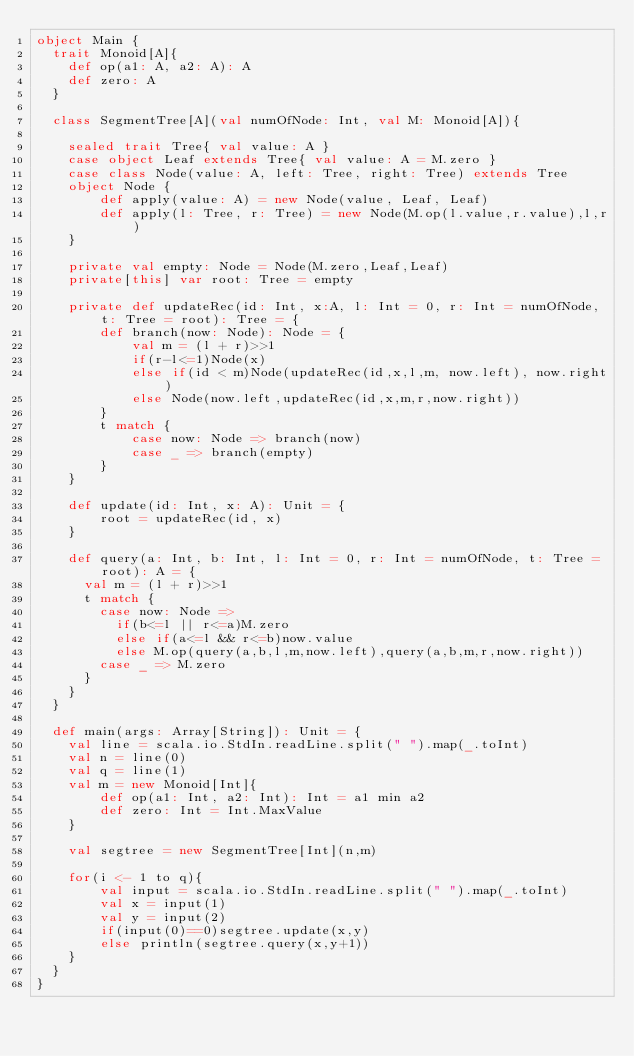Convert code to text. <code><loc_0><loc_0><loc_500><loc_500><_Scala_>object Main {
  trait Monoid[A]{
    def op(a1: A, a2: A): A
    def zero: A
  }

  class SegmentTree[A](val numOfNode: Int, val M: Monoid[A]){

    sealed trait Tree{ val value: A }
    case object Leaf extends Tree{ val value: A = M.zero }
    case class Node(value: A, left: Tree, right: Tree) extends Tree
    object Node {
        def apply(value: A) = new Node(value, Leaf, Leaf)
        def apply(l: Tree, r: Tree) = new Node(M.op(l.value,r.value),l,r)
    }

    private val empty: Node = Node(M.zero,Leaf,Leaf)
    private[this] var root: Tree = empty

    private def updateRec(id: Int, x:A, l: Int = 0, r: Int = numOfNode, t: Tree = root): Tree = {
        def branch(now: Node): Node = {
            val m = (l + r)>>1
            if(r-l<=1)Node(x)
            else if(id < m)Node(updateRec(id,x,l,m, now.left), now.right)
            else Node(now.left,updateRec(id,x,m,r,now.right))
        }
        t match {
            case now: Node => branch(now)
            case _ => branch(empty)
        }
    }

    def update(id: Int, x: A): Unit = {
        root = updateRec(id, x)
    }

    def query(a: Int, b: Int, l: Int = 0, r: Int = numOfNode, t: Tree = root): A = {
      val m = (l + r)>>1
      t match {
        case now: Node =>
          if(b<=l || r<=a)M.zero
          else if(a<=l && r<=b)now.value
          else M.op(query(a,b,l,m,now.left),query(a,b,m,r,now.right))
        case _ => M.zero
      }
    }
  }

  def main(args: Array[String]): Unit = {
    val line = scala.io.StdIn.readLine.split(" ").map(_.toInt)
    val n = line(0)
    val q = line(1)
    val m = new Monoid[Int]{
        def op(a1: Int, a2: Int): Int = a1 min a2
        def zero: Int = Int.MaxValue
    }

    val segtree = new SegmentTree[Int](n,m)

    for(i <- 1 to q){
        val input = scala.io.StdIn.readLine.split(" ").map(_.toInt)
        val x = input(1)
        val y = input(2)
        if(input(0)==0)segtree.update(x,y)
        else println(segtree.query(x,y+1))
    }
  }
}</code> 